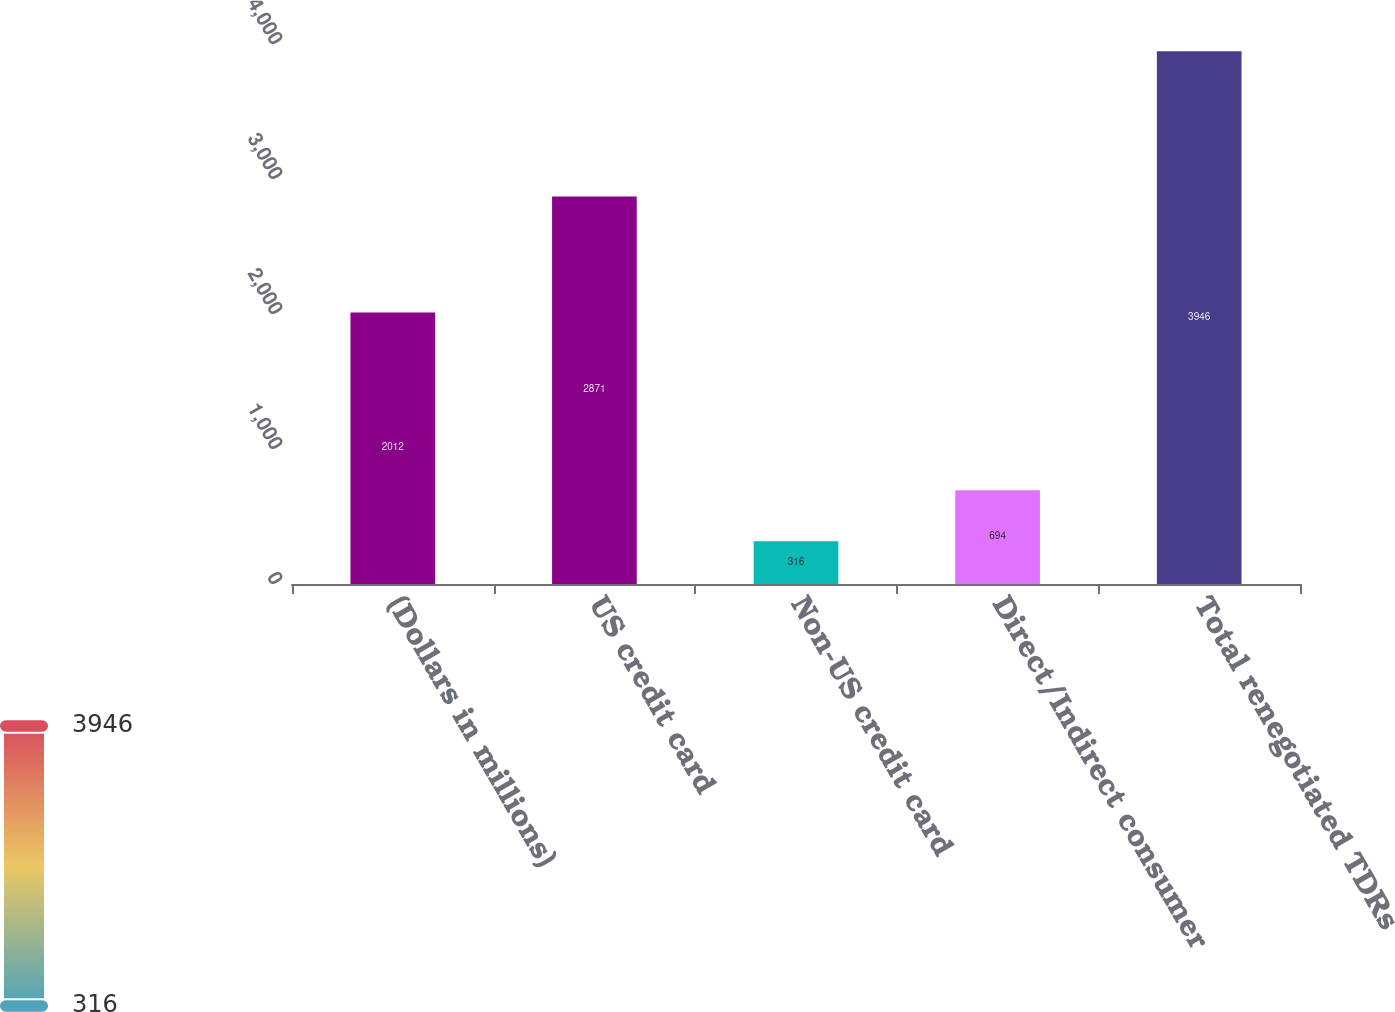<chart> <loc_0><loc_0><loc_500><loc_500><bar_chart><fcel>(Dollars in millions)<fcel>US credit card<fcel>Non-US credit card<fcel>Direct/Indirect consumer<fcel>Total renegotiated TDRs<nl><fcel>2012<fcel>2871<fcel>316<fcel>694<fcel>3946<nl></chart> 